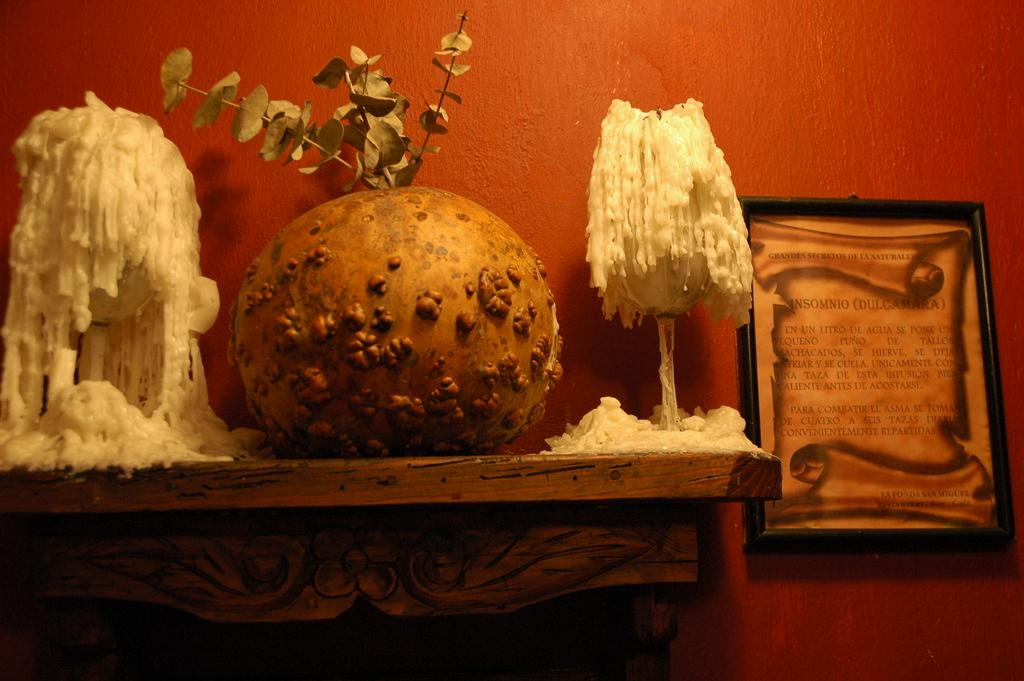What is on the table in the image? There are objects on a table in the image. Can you describe any specific item on the right side of the image? There is a photo frame on the right side of the image. How is the photo frame positioned in the image? The photo frame is attached to the wall. How many eyes can be seen on the objects in the image? There is no information about eyes on the objects in the image, as the facts provided do not mention anything about eyes or living beings. 